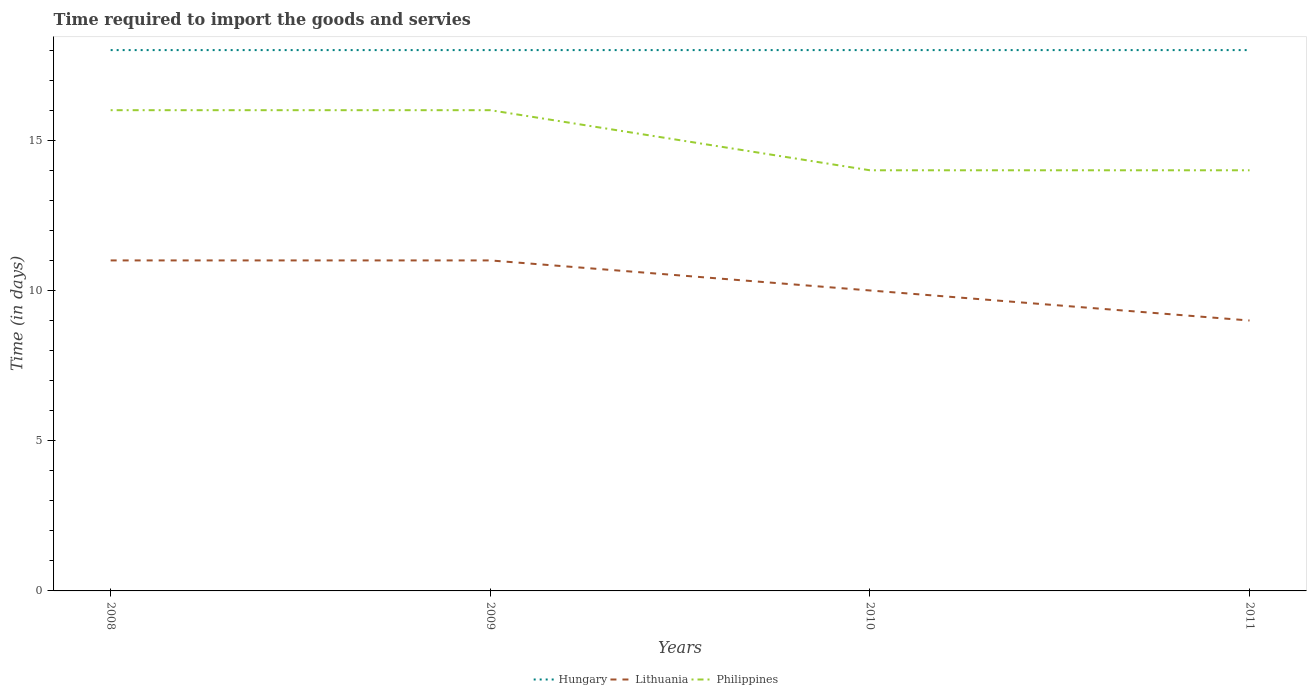How many different coloured lines are there?
Provide a succinct answer. 3. Does the line corresponding to Philippines intersect with the line corresponding to Lithuania?
Provide a succinct answer. No. Across all years, what is the maximum number of days required to import the goods and services in Philippines?
Your response must be concise. 14. What is the difference between the highest and the second highest number of days required to import the goods and services in Lithuania?
Give a very brief answer. 2. How many lines are there?
Your response must be concise. 3. Are the values on the major ticks of Y-axis written in scientific E-notation?
Provide a succinct answer. No. Does the graph contain any zero values?
Provide a succinct answer. No. Does the graph contain grids?
Keep it short and to the point. No. How are the legend labels stacked?
Make the answer very short. Horizontal. What is the title of the graph?
Your response must be concise. Time required to import the goods and servies. Does "Iran" appear as one of the legend labels in the graph?
Ensure brevity in your answer.  No. What is the label or title of the X-axis?
Your response must be concise. Years. What is the label or title of the Y-axis?
Offer a very short reply. Time (in days). What is the Time (in days) of Hungary in 2008?
Your answer should be compact. 18. What is the Time (in days) in Lithuania in 2008?
Give a very brief answer. 11. What is the Time (in days) in Philippines in 2008?
Offer a very short reply. 16. What is the Time (in days) in Lithuania in 2009?
Keep it short and to the point. 11. What is the Time (in days) of Philippines in 2009?
Provide a short and direct response. 16. What is the Time (in days) of Hungary in 2010?
Keep it short and to the point. 18. What is the Time (in days) of Lithuania in 2010?
Keep it short and to the point. 10. What is the Time (in days) in Philippines in 2010?
Your response must be concise. 14. What is the Time (in days) in Hungary in 2011?
Your response must be concise. 18. What is the Time (in days) of Philippines in 2011?
Make the answer very short. 14. Across all years, what is the maximum Time (in days) in Hungary?
Make the answer very short. 18. Across all years, what is the maximum Time (in days) of Lithuania?
Keep it short and to the point. 11. Across all years, what is the minimum Time (in days) in Lithuania?
Make the answer very short. 9. What is the total Time (in days) in Lithuania in the graph?
Give a very brief answer. 41. What is the total Time (in days) of Philippines in the graph?
Provide a short and direct response. 60. What is the difference between the Time (in days) in Hungary in 2008 and that in 2009?
Make the answer very short. 0. What is the difference between the Time (in days) of Lithuania in 2008 and that in 2009?
Provide a succinct answer. 0. What is the difference between the Time (in days) in Philippines in 2008 and that in 2009?
Provide a short and direct response. 0. What is the difference between the Time (in days) of Hungary in 2008 and that in 2011?
Provide a short and direct response. 0. What is the difference between the Time (in days) of Lithuania in 2008 and that in 2011?
Your answer should be compact. 2. What is the difference between the Time (in days) of Philippines in 2008 and that in 2011?
Your answer should be very brief. 2. What is the difference between the Time (in days) in Hungary in 2009 and that in 2011?
Ensure brevity in your answer.  0. What is the difference between the Time (in days) of Lithuania in 2009 and that in 2011?
Your answer should be very brief. 2. What is the difference between the Time (in days) in Hungary in 2010 and that in 2011?
Your answer should be compact. 0. What is the difference between the Time (in days) in Philippines in 2010 and that in 2011?
Give a very brief answer. 0. What is the difference between the Time (in days) in Hungary in 2008 and the Time (in days) in Lithuania in 2009?
Your response must be concise. 7. What is the difference between the Time (in days) of Hungary in 2008 and the Time (in days) of Philippines in 2009?
Make the answer very short. 2. What is the difference between the Time (in days) in Hungary in 2008 and the Time (in days) in Philippines in 2010?
Make the answer very short. 4. What is the difference between the Time (in days) of Lithuania in 2008 and the Time (in days) of Philippines in 2010?
Give a very brief answer. -3. What is the difference between the Time (in days) of Hungary in 2008 and the Time (in days) of Philippines in 2011?
Offer a terse response. 4. What is the difference between the Time (in days) in Lithuania in 2008 and the Time (in days) in Philippines in 2011?
Ensure brevity in your answer.  -3. What is the difference between the Time (in days) in Hungary in 2009 and the Time (in days) in Philippines in 2010?
Make the answer very short. 4. What is the difference between the Time (in days) of Hungary in 2009 and the Time (in days) of Philippines in 2011?
Ensure brevity in your answer.  4. What is the difference between the Time (in days) in Lithuania in 2009 and the Time (in days) in Philippines in 2011?
Give a very brief answer. -3. What is the difference between the Time (in days) of Hungary in 2010 and the Time (in days) of Philippines in 2011?
Keep it short and to the point. 4. What is the difference between the Time (in days) of Lithuania in 2010 and the Time (in days) of Philippines in 2011?
Make the answer very short. -4. What is the average Time (in days) in Hungary per year?
Offer a very short reply. 18. What is the average Time (in days) in Lithuania per year?
Give a very brief answer. 10.25. In the year 2008, what is the difference between the Time (in days) of Hungary and Time (in days) of Philippines?
Your answer should be compact. 2. In the year 2009, what is the difference between the Time (in days) of Lithuania and Time (in days) of Philippines?
Make the answer very short. -5. In the year 2010, what is the difference between the Time (in days) in Lithuania and Time (in days) in Philippines?
Make the answer very short. -4. In the year 2011, what is the difference between the Time (in days) of Hungary and Time (in days) of Lithuania?
Offer a very short reply. 9. In the year 2011, what is the difference between the Time (in days) in Hungary and Time (in days) in Philippines?
Provide a succinct answer. 4. In the year 2011, what is the difference between the Time (in days) of Lithuania and Time (in days) of Philippines?
Offer a very short reply. -5. What is the ratio of the Time (in days) in Lithuania in 2008 to that in 2009?
Make the answer very short. 1. What is the ratio of the Time (in days) of Philippines in 2008 to that in 2010?
Give a very brief answer. 1.14. What is the ratio of the Time (in days) of Lithuania in 2008 to that in 2011?
Provide a succinct answer. 1.22. What is the ratio of the Time (in days) in Hungary in 2009 to that in 2010?
Provide a succinct answer. 1. What is the ratio of the Time (in days) of Lithuania in 2009 to that in 2010?
Ensure brevity in your answer.  1.1. What is the ratio of the Time (in days) in Hungary in 2009 to that in 2011?
Keep it short and to the point. 1. What is the ratio of the Time (in days) in Lithuania in 2009 to that in 2011?
Give a very brief answer. 1.22. What is the ratio of the Time (in days) of Philippines in 2010 to that in 2011?
Keep it short and to the point. 1. What is the difference between the highest and the second highest Time (in days) in Hungary?
Provide a short and direct response. 0. 